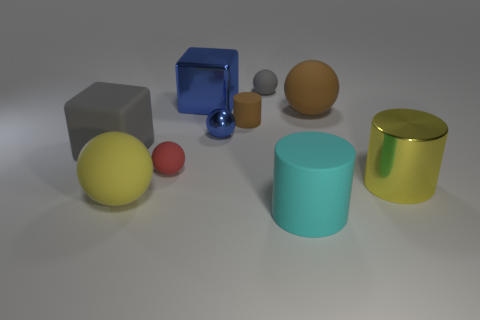Is there a gray cube that has the same size as the brown ball?
Give a very brief answer. Yes. What is the color of the block that is the same material as the large cyan cylinder?
Give a very brief answer. Gray. Are there fewer gray cubes than small cyan metal cylinders?
Ensure brevity in your answer.  No. What material is the thing that is behind the big gray matte block and right of the small gray object?
Ensure brevity in your answer.  Rubber. There is a small matte sphere that is in front of the large brown rubber thing; is there a small blue metal sphere that is left of it?
Provide a short and direct response. No. How many objects are the same color as the large metallic block?
Your response must be concise. 1. There is another thing that is the same color as the small metallic object; what material is it?
Offer a very short reply. Metal. Do the big brown sphere and the small red object have the same material?
Your answer should be very brief. Yes. There is a cyan cylinder; are there any large rubber blocks in front of it?
Provide a succinct answer. No. What is the material of the yellow thing that is left of the large blue shiny object behind the red matte sphere?
Ensure brevity in your answer.  Rubber. 